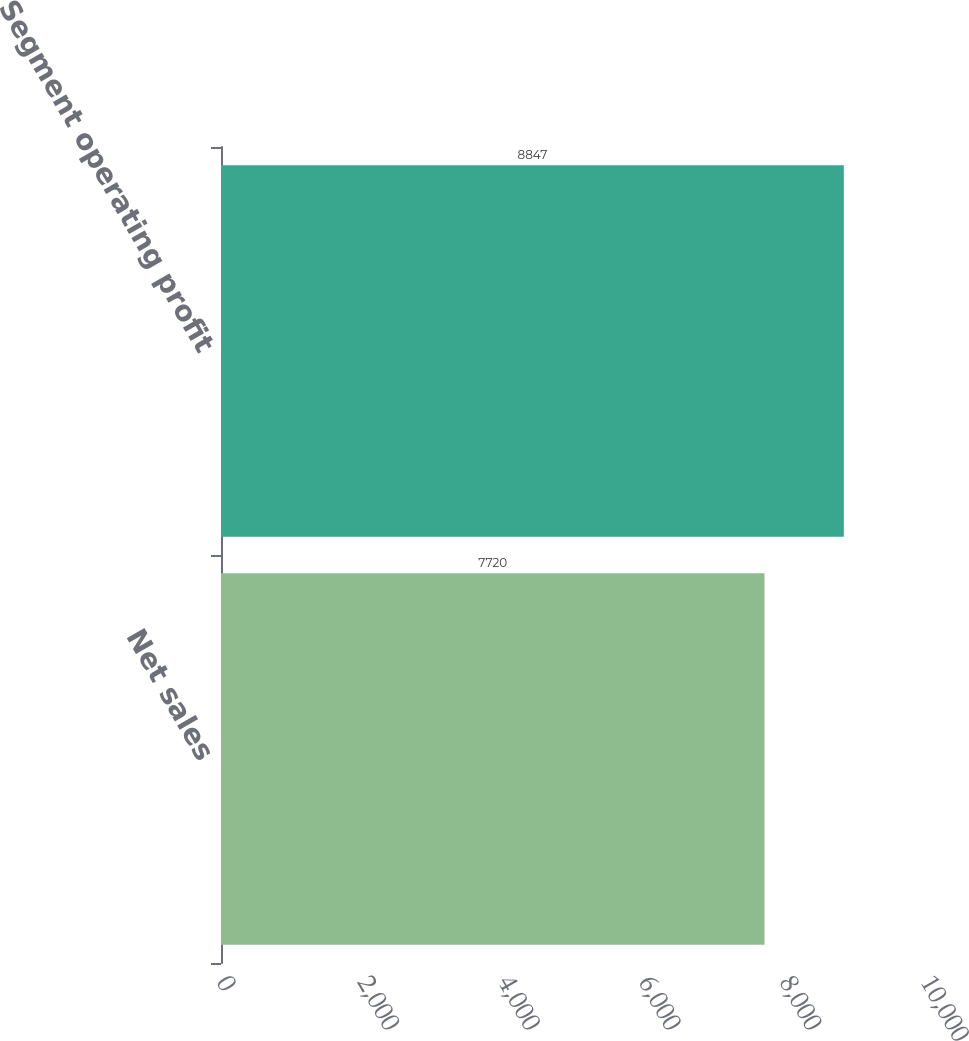<chart> <loc_0><loc_0><loc_500><loc_500><bar_chart><fcel>Net sales<fcel>Segment operating profit<nl><fcel>7720<fcel>8847<nl></chart> 